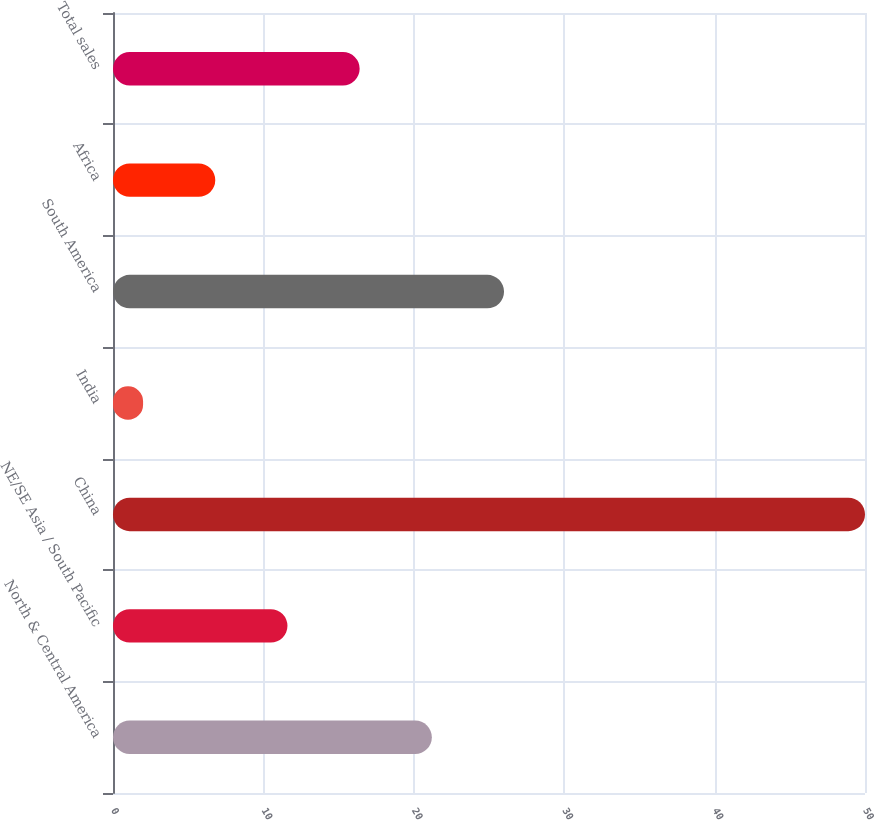Convert chart to OTSL. <chart><loc_0><loc_0><loc_500><loc_500><bar_chart><fcel>North & Central America<fcel>NE/SE Asia / South Pacific<fcel>China<fcel>India<fcel>South America<fcel>Africa<fcel>Total sales<nl><fcel>21.2<fcel>11.6<fcel>50<fcel>2<fcel>26<fcel>6.8<fcel>16.4<nl></chart> 